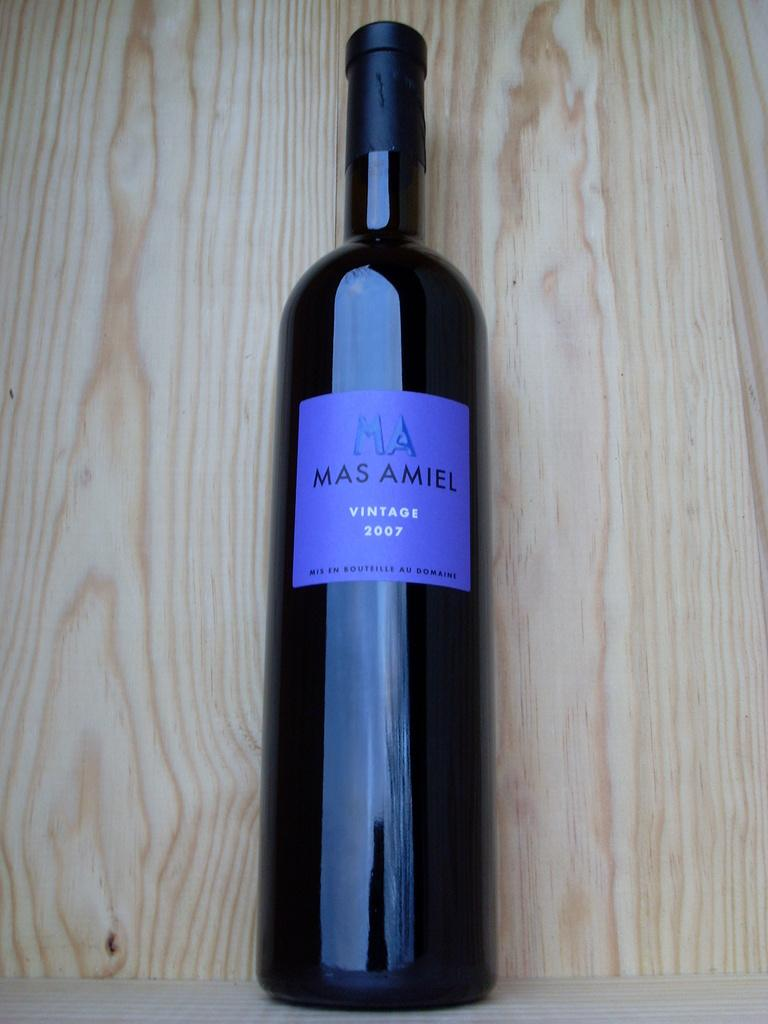What is the main object in the image? There is a wine bottle in the image. Can you describe any distinguishing features of the wine bottle? The wine bottle has a blue sticker on it. Where is the wine bottle located in the image? The wine bottle is kept in a wooden rack. What type of punishment is being administered to the salt in the image? There is no salt present in the image, and therefore no punishment can be observed. 